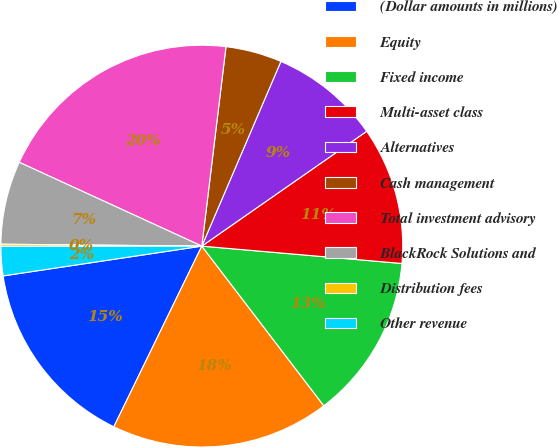Convert chart. <chart><loc_0><loc_0><loc_500><loc_500><pie_chart><fcel>(Dollar amounts in millions)<fcel>Equity<fcel>Fixed income<fcel>Multi-asset class<fcel>Alternatives<fcel>Cash management<fcel>Total investment advisory<fcel>BlackRock Solutions and<fcel>Distribution fees<fcel>Other revenue<nl><fcel>15.42%<fcel>17.6%<fcel>13.24%<fcel>11.06%<fcel>8.88%<fcel>4.52%<fcel>20.07%<fcel>6.7%<fcel>0.17%<fcel>2.35%<nl></chart> 